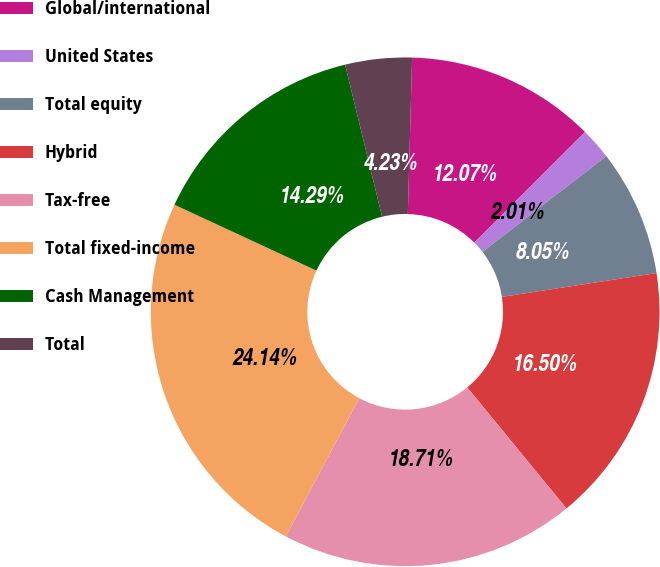<chart> <loc_0><loc_0><loc_500><loc_500><pie_chart><fcel>Global/international<fcel>United States<fcel>Total equity<fcel>Hybrid<fcel>Tax-free<fcel>Total fixed-income<fcel>Cash Management<fcel>Total<nl><fcel>12.07%<fcel>2.01%<fcel>8.05%<fcel>16.5%<fcel>18.71%<fcel>24.14%<fcel>14.29%<fcel>4.23%<nl></chart> 